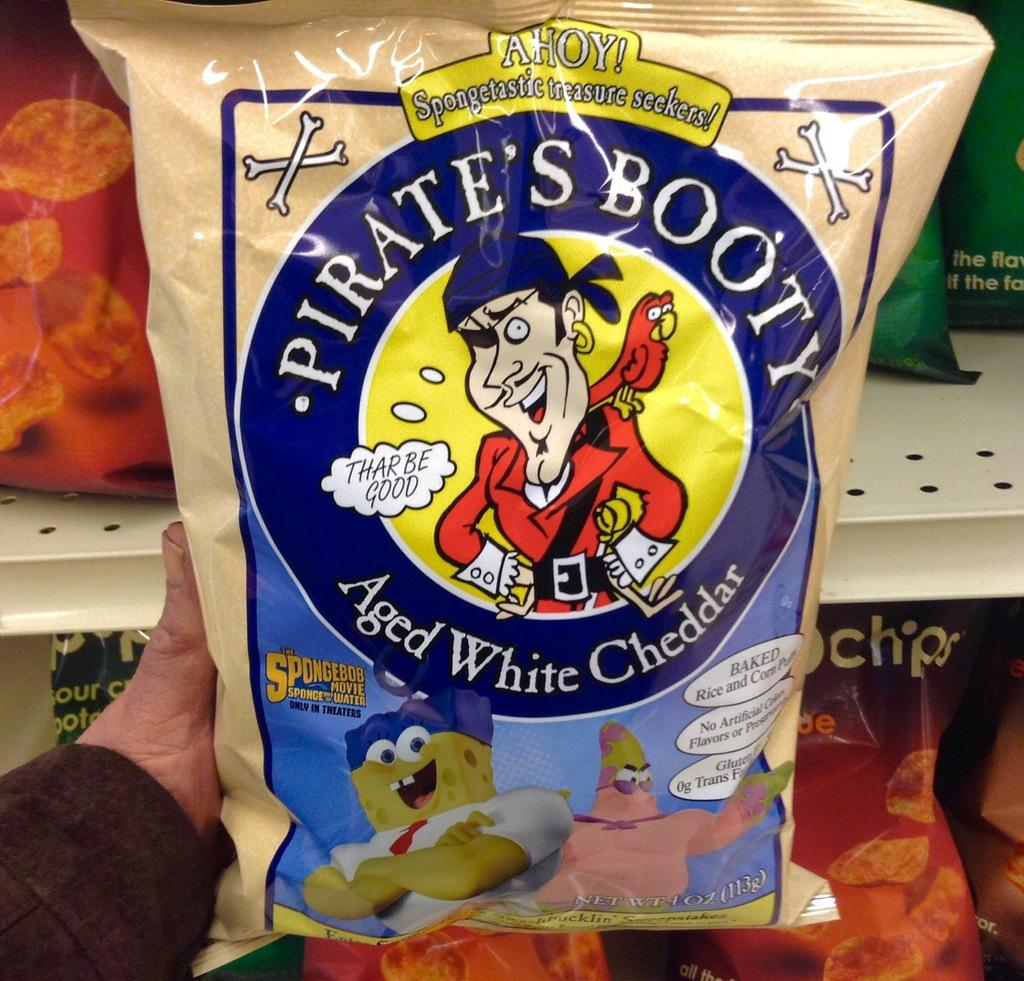What is the person holding in the image? The person is holding a cheddar packet in the image. What can be seen in the background of the image? There are chips packets arranged in racks in the background of the image. What type of harmony is being played in the background of the image? There is no music or harmony present in the image; it features a person holding a cheddar packet and chips packets arranged in racks. 